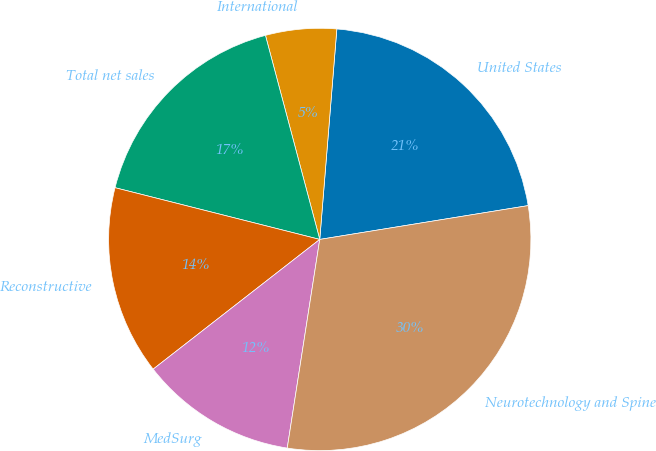<chart> <loc_0><loc_0><loc_500><loc_500><pie_chart><fcel>United States<fcel>International<fcel>Total net sales<fcel>Reconstructive<fcel>MedSurg<fcel>Neurotechnology and Spine<nl><fcel>21.15%<fcel>5.43%<fcel>16.92%<fcel>14.47%<fcel>12.01%<fcel>30.02%<nl></chart> 